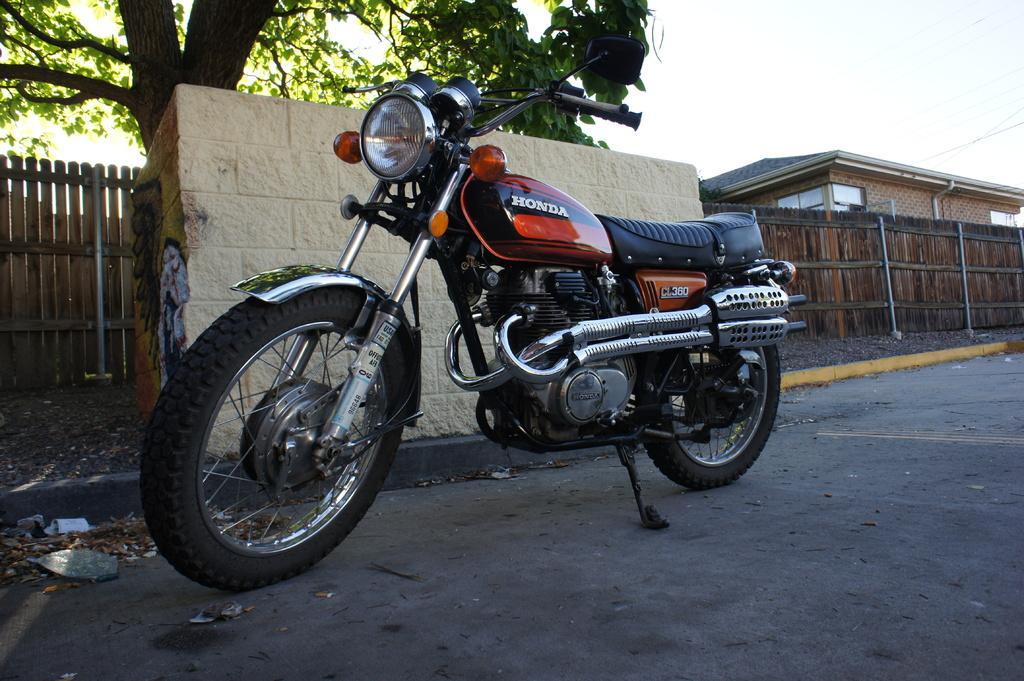In one or two sentences, can you explain what this image depicts? In the image I can see the ground, a motor bike which is orange and black in color on the ground, the wooden fencing, a tree which is green and black in color and a building. In the background I can see the sky. 